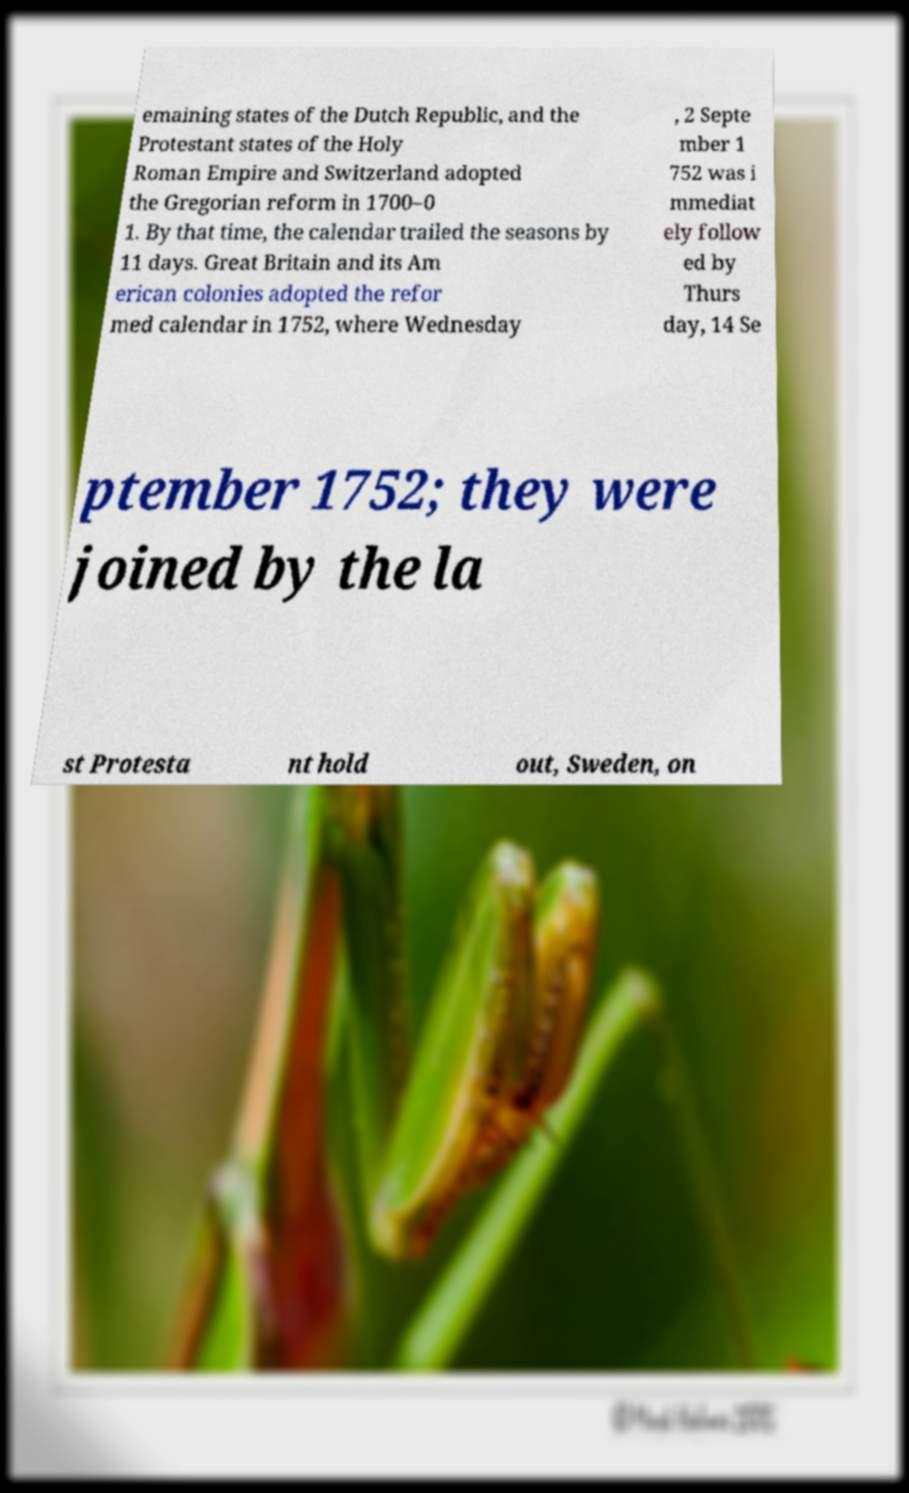Please read and relay the text visible in this image. What does it say? emaining states of the Dutch Republic, and the Protestant states of the Holy Roman Empire and Switzerland adopted the Gregorian reform in 1700–0 1. By that time, the calendar trailed the seasons by 11 days. Great Britain and its Am erican colonies adopted the refor med calendar in 1752, where Wednesday , 2 Septe mber 1 752 was i mmediat ely follow ed by Thurs day, 14 Se ptember 1752; they were joined by the la st Protesta nt hold out, Sweden, on 